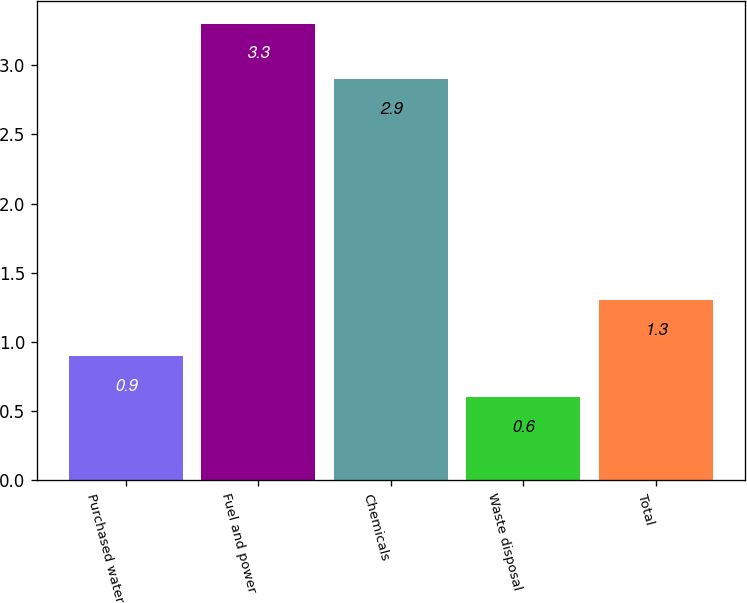Convert chart. <chart><loc_0><loc_0><loc_500><loc_500><bar_chart><fcel>Purchased water<fcel>Fuel and power<fcel>Chemicals<fcel>Waste disposal<fcel>Total<nl><fcel>0.9<fcel>3.3<fcel>2.9<fcel>0.6<fcel>1.3<nl></chart> 